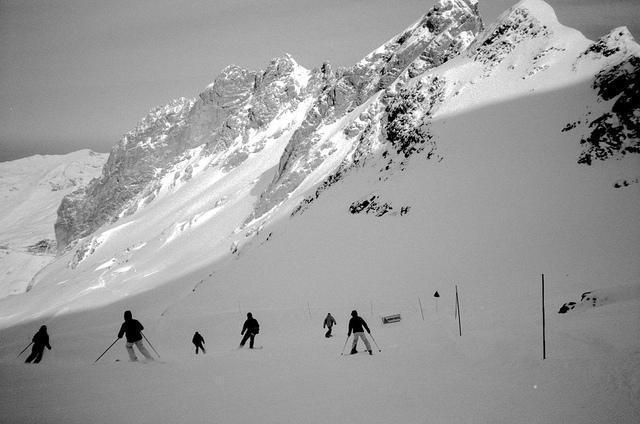How many people are skiing?
Give a very brief answer. 6. How many suitcases are there?
Give a very brief answer. 0. 